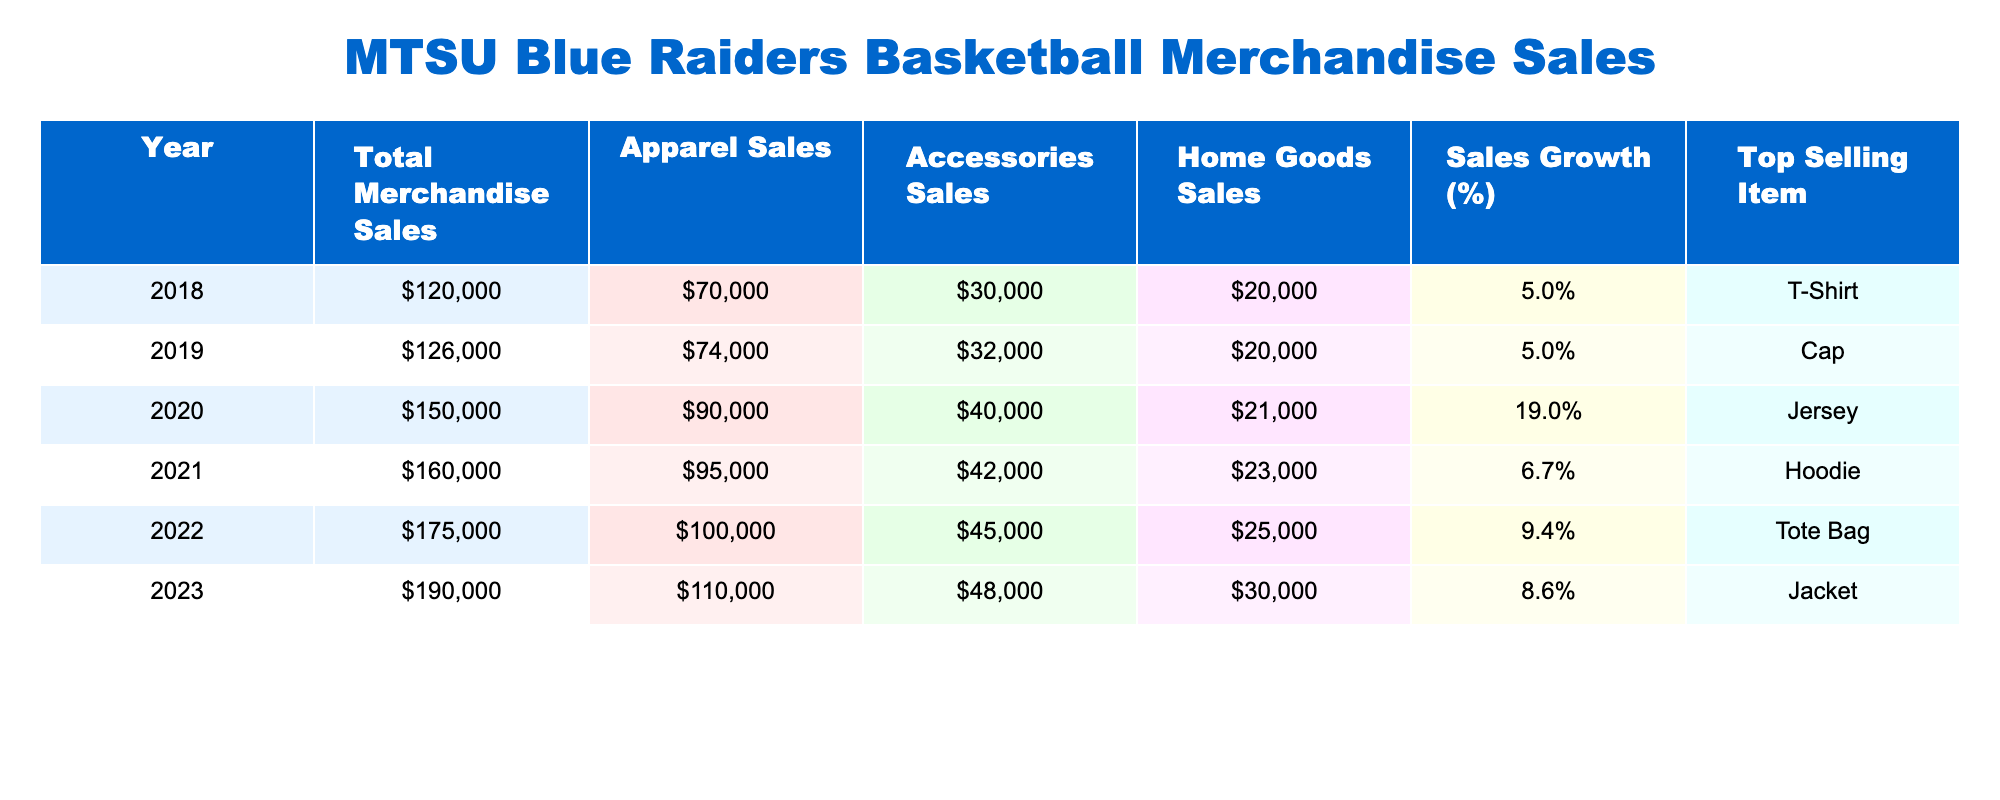What was the total merchandise sales in 2022? The total merchandise sales for the year 2022 is shown in the table. According to the table, it lists $175,000 as the figure for that year.
Answer: $175,000 Which year had the highest sales growth percentage? To find the highest sales growth percentage, I compare each year's sales growth values. The growth percentages are 5.0%, 5.0%, 19.0%, 6.7%, 9.4%, and 8.6%. The highest is 19.0% in 2020.
Answer: 2020 What is the difference in total merchandise sales between 2023 and 2021? The total merchandise sales for 2023 is $190,000 and for 2021 it is $160,000. The difference can be calculated as $190,000 - $160,000 = $30,000.
Answer: $30,000 Which top-selling item had the highest revenue in 2020? The table provides the top-selling items for respective years and their sales data. In 2020, the top-selling item was a Jersey, and the total sales that year were $150,000.
Answer: Jersey What was the average apparel sales for the years 2019 to 2023? I need to sum the apparel sales from 2019 to 2023: $74,000 + $90,000 + $95,000 + $100,000 + $110,000 = $469,000. There are 5 years, so average is $469,000 / 5 = $93,800.
Answer: $93,800 Is it true that accessories sales were higher in 2021 than in 2019? The accessories sales for 2021 were $42,000, while for 2019 they were $32,000. Since $42,000 is greater than $32,000, the statement is true.
Answer: Yes What was the total home goods sales for 2020? According to the table, home goods sales for 2020 is listed as $21,000. This value is directly visible in the provided data.
Answer: $21,000 If the sales growth percentage for 2022 was subtracted from the sales growth percentage for 2023, what would the result be? The sales growth percentage for 2023 is 8.6% and for 2022 is 9.4%. The difference is calculated as 8.6% - 9.4% = -0.8%.
Answer: -0.8% In which year did apparel sales first exceed $90,000? Looking through the apparel sales data, apparel sales exceeded $90,000 for the first time in 2020 when it reached $90,000 exactly.
Answer: 2020 What is the trend in total merchandise sales from 2018 to 2023? By assessing the total merchandise sales across the years, they increased each year: $120,000 in 2018 to $190,000 in 2023. This indicates a consistent upward trend in sales.
Answer: Upward trend 